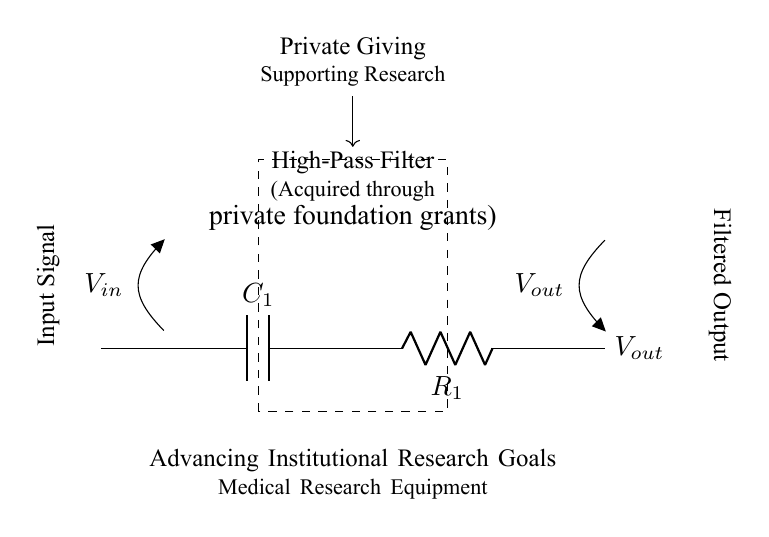What type of filter is represented in the circuit? The circuit represents a high-pass filter, which is indicated specifically in the labelling within the dashed rectangle. High-pass filters allow signals with a frequency higher than a certain cutoff frequency to pass through.
Answer: High-pass filter What are the components used in the circuit? The circuit uses a capacitor labeled C1 and a resistor labeled R1. These components are shown in sequence with their respective labels.
Answer: Capacitor and resistor What is the function of the capacitor in this filter? The capacitor in a high-pass filter blocks low-frequency signals, allowing higher frequencies to pass through. This is a key characteristic of capacitors in such circuit configurations.
Answer: Blocks low frequencies What is the function of the resistor in this filter? The resistor in this configuration works alongside the capacitor to determine the cutoff frequency of the filter. It influences how quickly the circuit responds to changes in the input signal.
Answer: Sets cutoff frequency What is the nature of the input signal for this filter? The input signal is typically an alternating current signal or varying voltage that contains both low and high-frequency components. The label V_in specifies this nature in the circuit diagram.
Answer: Alternating current How does private giving influence the acquisition of this equipment? Private giving through foundation grants allows the institution to acquire essential medical research equipment, which fundamentally supports their research goals and advancements in the field.
Answer: Supports research acquisition What institutional goal is advanced with this equipment? The goal advanced is medical research, as indicated in the phrasing below the filter's label regarding institutional research objectives. This emphasizes the purpose of the equipment.
Answer: Medical research 